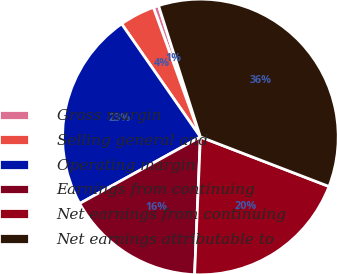Convert chart to OTSL. <chart><loc_0><loc_0><loc_500><loc_500><pie_chart><fcel>Gross margin<fcel>Selling general and<fcel>Operating margin<fcel>Earnings from continuing<fcel>Net earnings from continuing<fcel>Net earnings attributable to<nl><fcel>0.63%<fcel>4.14%<fcel>23.34%<fcel>16.31%<fcel>19.82%<fcel>35.76%<nl></chart> 